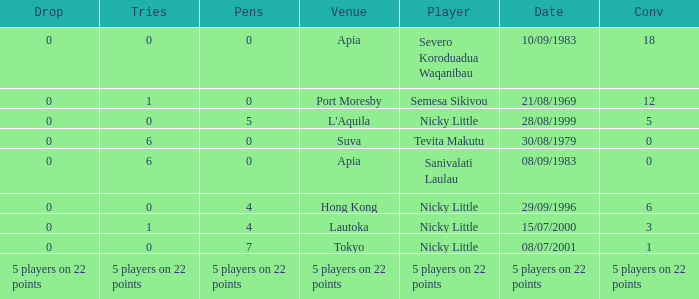How many conversions did Severo Koroduadua Waqanibau have when he has 0 pens? 18.0. Can you parse all the data within this table? {'header': ['Drop', 'Tries', 'Pens', 'Venue', 'Player', 'Date', 'Conv'], 'rows': [['0', '0', '0', 'Apia', 'Severo Koroduadua Waqanibau', '10/09/1983', '18'], ['0', '1', '0', 'Port Moresby', 'Semesa Sikivou', '21/08/1969', '12'], ['0', '0', '5', "L'Aquila", 'Nicky Little', '28/08/1999', '5'], ['0', '6', '0', 'Suva', 'Tevita Makutu', '30/08/1979', '0'], ['0', '6', '0', 'Apia', 'Sanivalati Laulau', '08/09/1983', '0'], ['0', '0', '4', 'Hong Kong', 'Nicky Little', '29/09/1996', '6'], ['0', '1', '4', 'Lautoka', 'Nicky Little', '15/07/2000', '3'], ['0', '0', '7', 'Tokyo', 'Nicky Little', '08/07/2001', '1'], ['5 players on 22 points', '5 players on 22 points', '5 players on 22 points', '5 players on 22 points', '5 players on 22 points', '5 players on 22 points', '5 players on 22 points']]} 